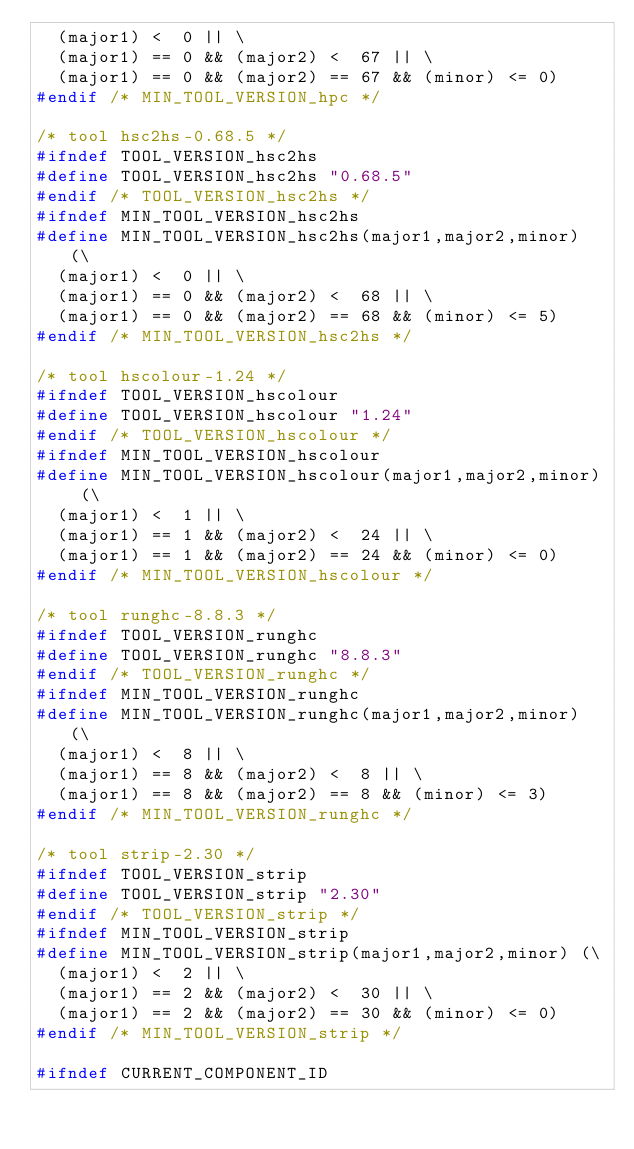Convert code to text. <code><loc_0><loc_0><loc_500><loc_500><_C_>  (major1) <  0 || \
  (major1) == 0 && (major2) <  67 || \
  (major1) == 0 && (major2) == 67 && (minor) <= 0)
#endif /* MIN_TOOL_VERSION_hpc */

/* tool hsc2hs-0.68.5 */
#ifndef TOOL_VERSION_hsc2hs
#define TOOL_VERSION_hsc2hs "0.68.5"
#endif /* TOOL_VERSION_hsc2hs */
#ifndef MIN_TOOL_VERSION_hsc2hs
#define MIN_TOOL_VERSION_hsc2hs(major1,major2,minor) (\
  (major1) <  0 || \
  (major1) == 0 && (major2) <  68 || \
  (major1) == 0 && (major2) == 68 && (minor) <= 5)
#endif /* MIN_TOOL_VERSION_hsc2hs */

/* tool hscolour-1.24 */
#ifndef TOOL_VERSION_hscolour
#define TOOL_VERSION_hscolour "1.24"
#endif /* TOOL_VERSION_hscolour */
#ifndef MIN_TOOL_VERSION_hscolour
#define MIN_TOOL_VERSION_hscolour(major1,major2,minor) (\
  (major1) <  1 || \
  (major1) == 1 && (major2) <  24 || \
  (major1) == 1 && (major2) == 24 && (minor) <= 0)
#endif /* MIN_TOOL_VERSION_hscolour */

/* tool runghc-8.8.3 */
#ifndef TOOL_VERSION_runghc
#define TOOL_VERSION_runghc "8.8.3"
#endif /* TOOL_VERSION_runghc */
#ifndef MIN_TOOL_VERSION_runghc
#define MIN_TOOL_VERSION_runghc(major1,major2,minor) (\
  (major1) <  8 || \
  (major1) == 8 && (major2) <  8 || \
  (major1) == 8 && (major2) == 8 && (minor) <= 3)
#endif /* MIN_TOOL_VERSION_runghc */

/* tool strip-2.30 */
#ifndef TOOL_VERSION_strip
#define TOOL_VERSION_strip "2.30"
#endif /* TOOL_VERSION_strip */
#ifndef MIN_TOOL_VERSION_strip
#define MIN_TOOL_VERSION_strip(major1,major2,minor) (\
  (major1) <  2 || \
  (major1) == 2 && (major2) <  30 || \
  (major1) == 2 && (major2) == 30 && (minor) <= 0)
#endif /* MIN_TOOL_VERSION_strip */

#ifndef CURRENT_COMPONENT_ID</code> 